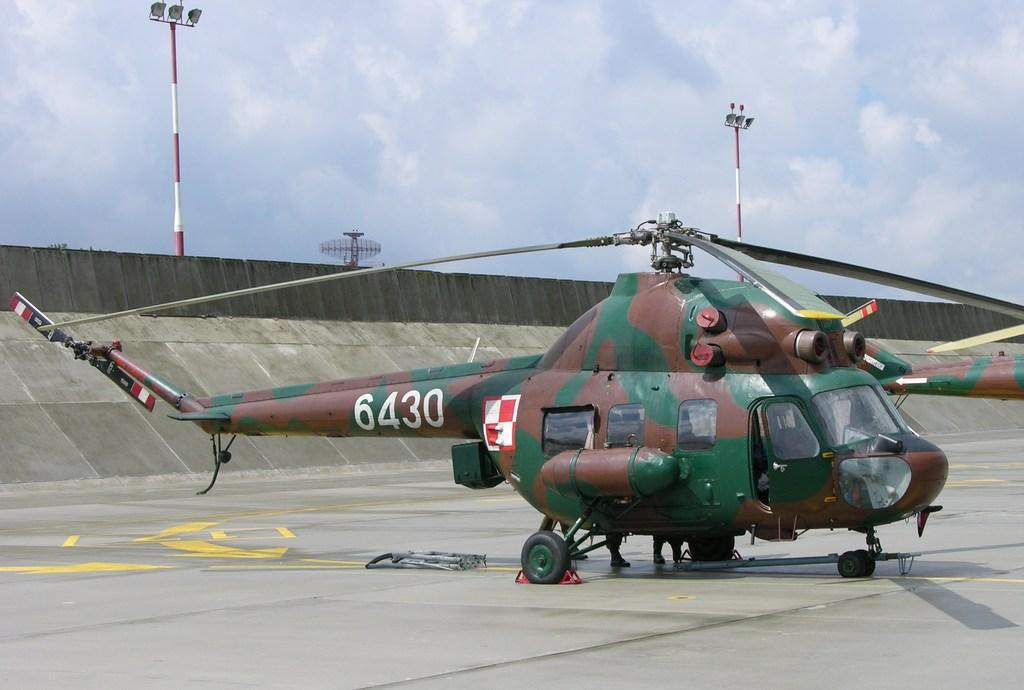What type of vehicle is on the ground in the image? There is a helicopter on the ground in the image. What structure can be seen in the image? There is a wall in the image. What are the tall, thin objects in the image? There are poles in the image. What is visible in the background of the image? The sky is visible in the background of the image. What can be seen in the sky? Clouds are present in the sky. What type of kite is being flown by the helicopter in the image? There is no kite present in the image, and the helicopter is on the ground, not flying. What message is being conveyed by the helicopter as it says good-bye in the image? Helicopters do not speak or convey messages in this manner, and there is no indication of a good-bye in the image. 